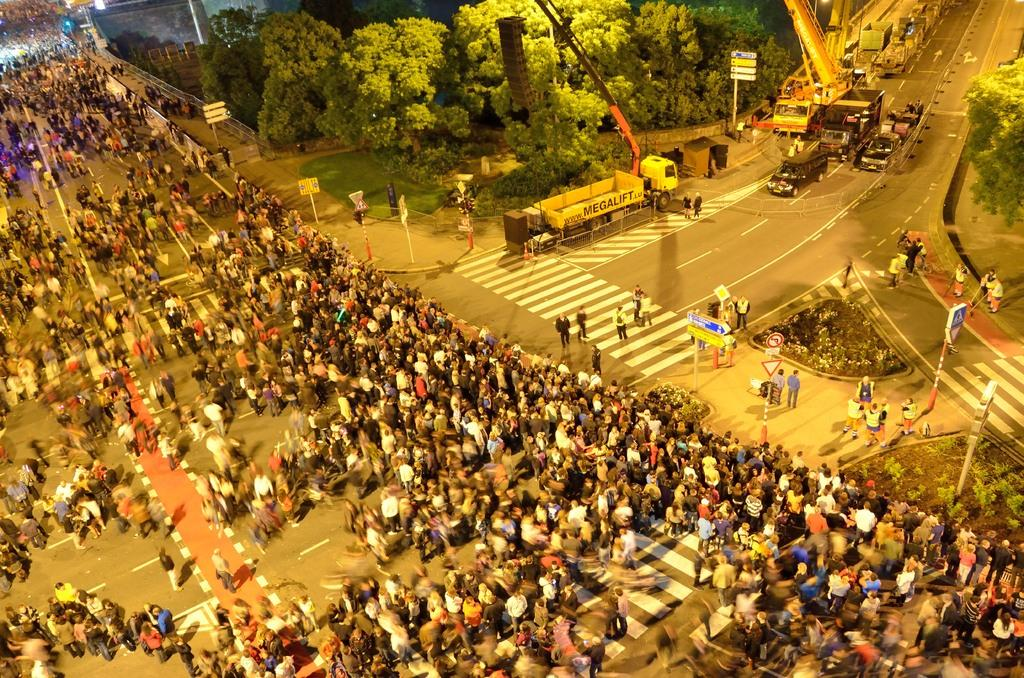What are the people in the image doing? There are persons standing on the road in the image. What objects can be seen in the image besides the people? There are poles, boards, vehicles, and green trees in the image. Can you see any beans growing on the trees in the image? There are no beans visible in the image, as the trees are green trees, not bean plants. 